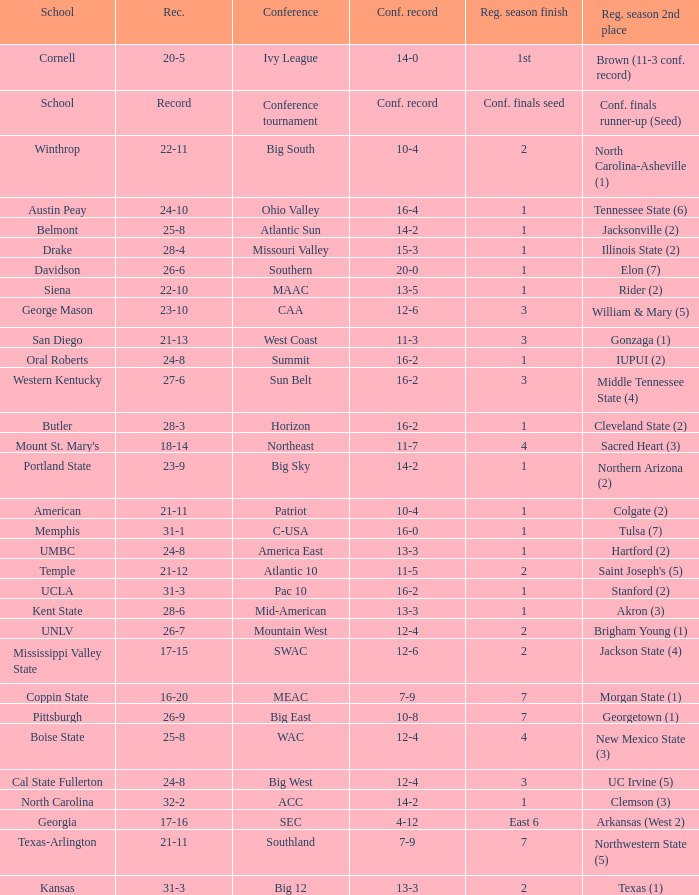What was the overall record of Oral Roberts college? 24-8. 